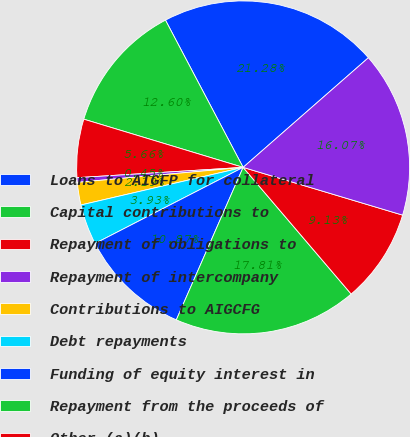Convert chart. <chart><loc_0><loc_0><loc_500><loc_500><pie_chart><fcel>Loans to AIGFP for collateral<fcel>Capital contributions to<fcel>Repayment of obligations to<fcel>Repayment of intercompany<fcel>Contributions to AIGCFG<fcel>Debt repayments<fcel>Funding of equity interest in<fcel>Repayment from the proceeds of<fcel>Other (a)(b)<fcel>Net borrowings<nl><fcel>21.28%<fcel>12.6%<fcel>5.66%<fcel>0.45%<fcel>2.19%<fcel>3.93%<fcel>10.87%<fcel>17.81%<fcel>9.13%<fcel>16.07%<nl></chart> 